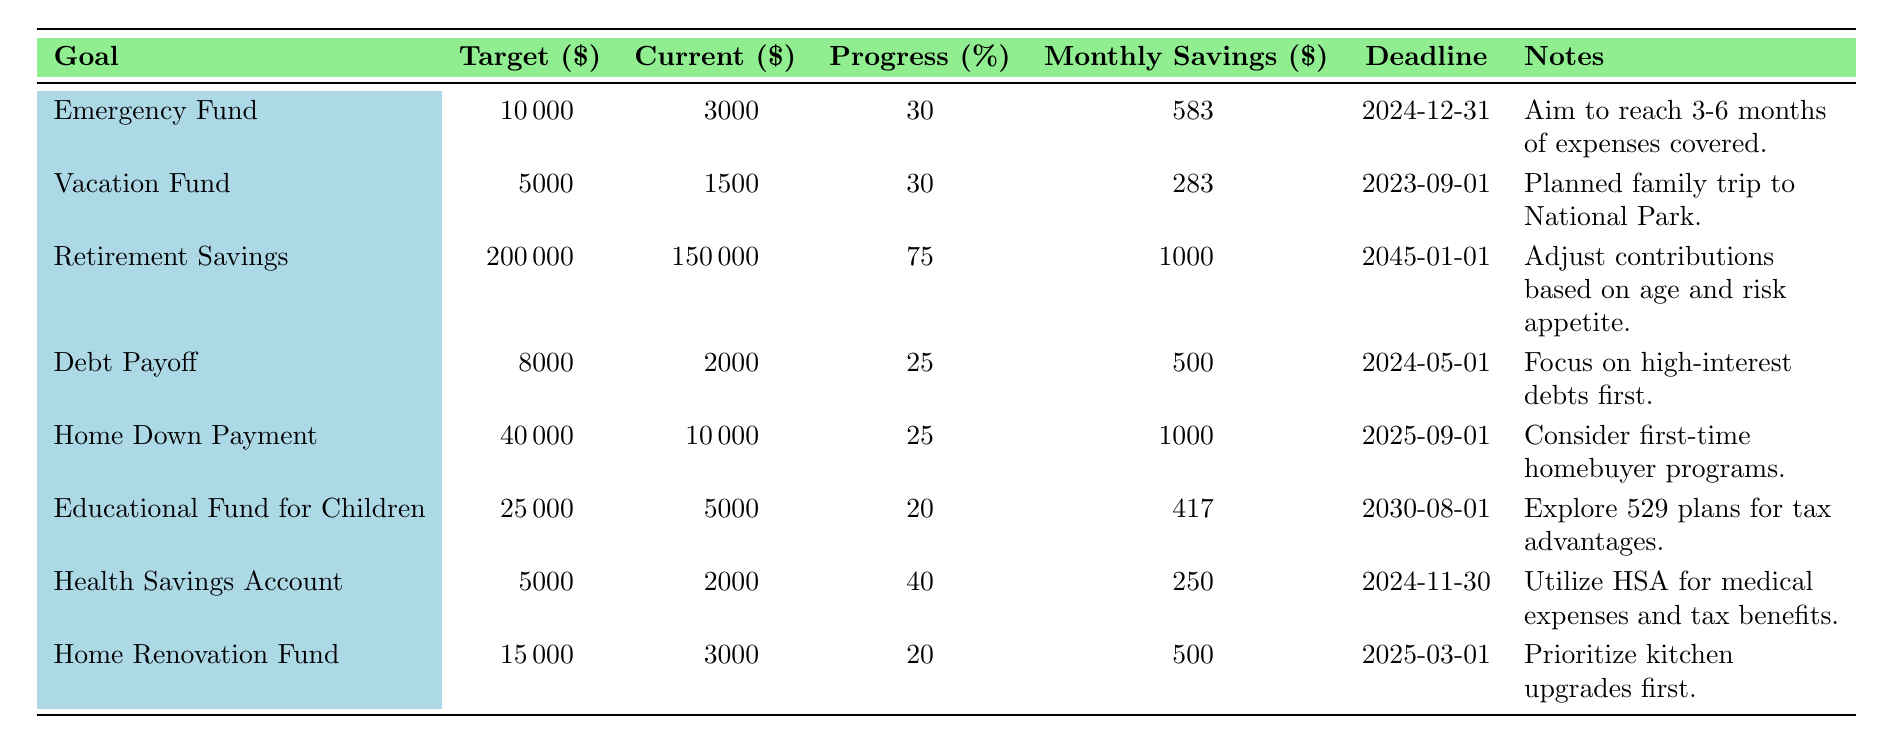What is the target amount for the Emergency Fund? The target amount is listed in the table under the "Target ($)" column for the Emergency Fund row, which shows 10,000.
Answer: 10,000 What is the current amount in the Vacation Fund? The current amount is listed in the table under the "Current ($)" column for the Vacation Fund row, which shows 1,500.
Answer: 1,500 Which goal has the highest progress percentage? By comparing the "Progress (%)" column values, Retirement Savings has the highest progress at 75 percent.
Answer: Retirement Savings How much monthly savings is required for the Health Savings Account? The required monthly savings amount is found in the "Monthly Savings ($)" column for the Health Savings Account row, which shows 250.
Answer: 250 What is the total target amount for the Debt Payoff and Home Down Payment goals? The target amounts for both goals are added together: 8,000 (Debt Payoff) + 40,000 (Home Down Payment) = 48,000.
Answer: 48,000 Is the Emergency Fund more than 50% of its target? The progress percentage is 30%, which is below 50%, so the statement is false.
Answer: No What is the difference between the target amount for the Home Renovation Fund and the current amount? The difference is calculated by subtracting the current amount (3,000) from the target amount (15,000): 15,000 - 3,000 = 12,000.
Answer: 12,000 How much total money has been saved across all goals so far? The total current amounts are summed: 3,000 (Emergency Fund) + 1,500 (Vacation Fund) + 150,000 (Retirement Savings) + 2,000 (Debt Payoff) + 10,000 (Home Down Payment) + 5,000 (Educational Fund) + 2,000 (Health Savings Account) + 3,000 (Home Renovation Fund) = 172,500.
Answer: 172,500 Which goal has the closest deadline? The deadlines are compared, and the Vacation Fund has the closest deadline on 2023-09-01.
Answer: Vacation Fund What is the average progress percentage across all listed goals? The average is calculated by adding all progress percentages (30 + 30 + 75 + 25 + 25 + 20 + 40 + 20 = 295) and dividing by the number of goals (8): 295 / 8 = 36.875.
Answer: 36.88 